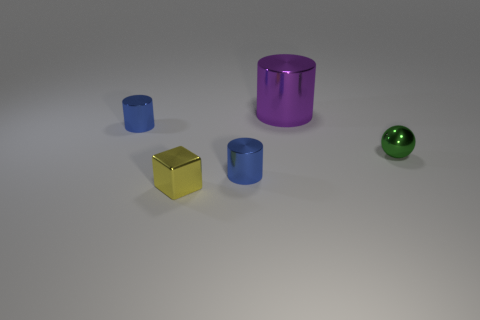There is a small cylinder that is in front of the small thing that is right of the purple cylinder; what is its material?
Keep it short and to the point. Metal. What color is the block that is the same size as the green metal ball?
Provide a succinct answer. Yellow. There is a tiny blue cylinder that is to the right of the yellow object to the left of the blue cylinder in front of the tiny green sphere; what is its material?
Your answer should be very brief. Metal. What is the shape of the blue shiny thing behind the small metal thing right of the big thing?
Your answer should be very brief. Cylinder. Are there any tiny blue things made of the same material as the small green ball?
Offer a terse response. Yes. Is the number of tiny green metallic balls right of the small green metallic object less than the number of purple metal objects that are in front of the block?
Offer a terse response. No. How many other objects are the same shape as the small green object?
Your response must be concise. 0. Is the number of large things that are on the left side of the big metal cylinder less than the number of tiny cylinders?
Offer a very short reply. Yes. How many other objects are the same size as the metallic sphere?
Your response must be concise. 3. Is the number of small metallic cylinders less than the number of tiny gray matte objects?
Provide a short and direct response. No. 